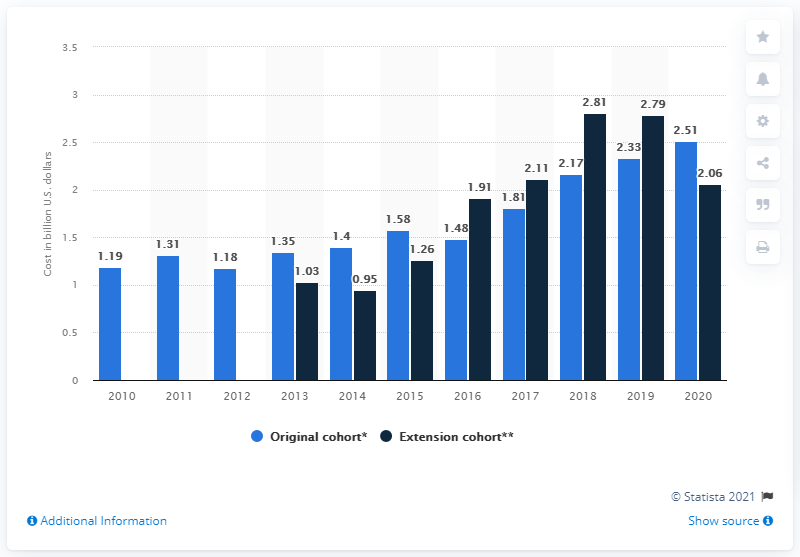Identify some key points in this picture. The mean cost to develop a compound in the original study cohort was 2.51 million dollars. 